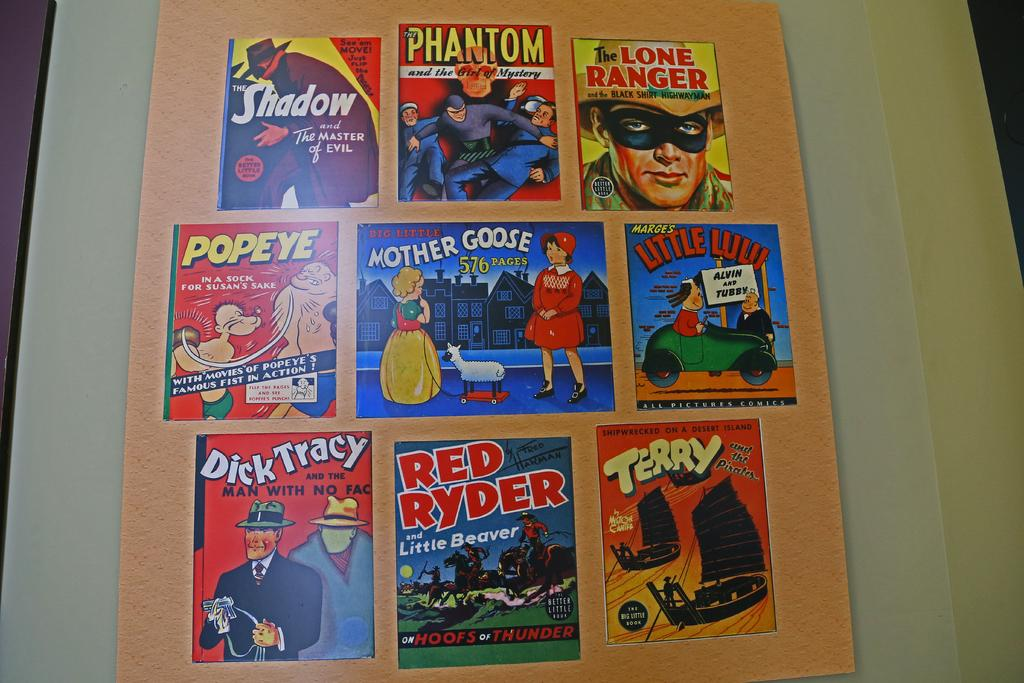What is attached to the wall in the image? There is a board on the wall in the image. What is on the board? There are posters on the board. What can be found on the posters? The posters contain text and images of cartoon characters. What type of pen is the creator using to draw the cartoon characters on the posters? There is no pen or creator present in the image; the cartoon characters are already on the posters. 